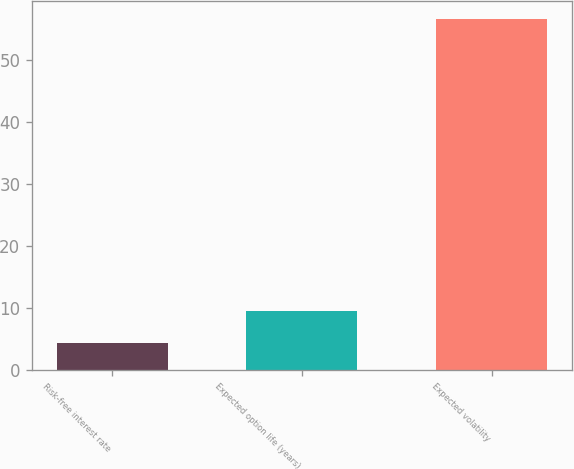Convert chart. <chart><loc_0><loc_0><loc_500><loc_500><bar_chart><fcel>Risk-free interest rate<fcel>Expected option life (years)<fcel>Expected volatility<nl><fcel>4.38<fcel>9.6<fcel>56.6<nl></chart> 